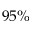Convert formula to latex. <formula><loc_0><loc_0><loc_500><loc_500>9 5 \%</formula> 